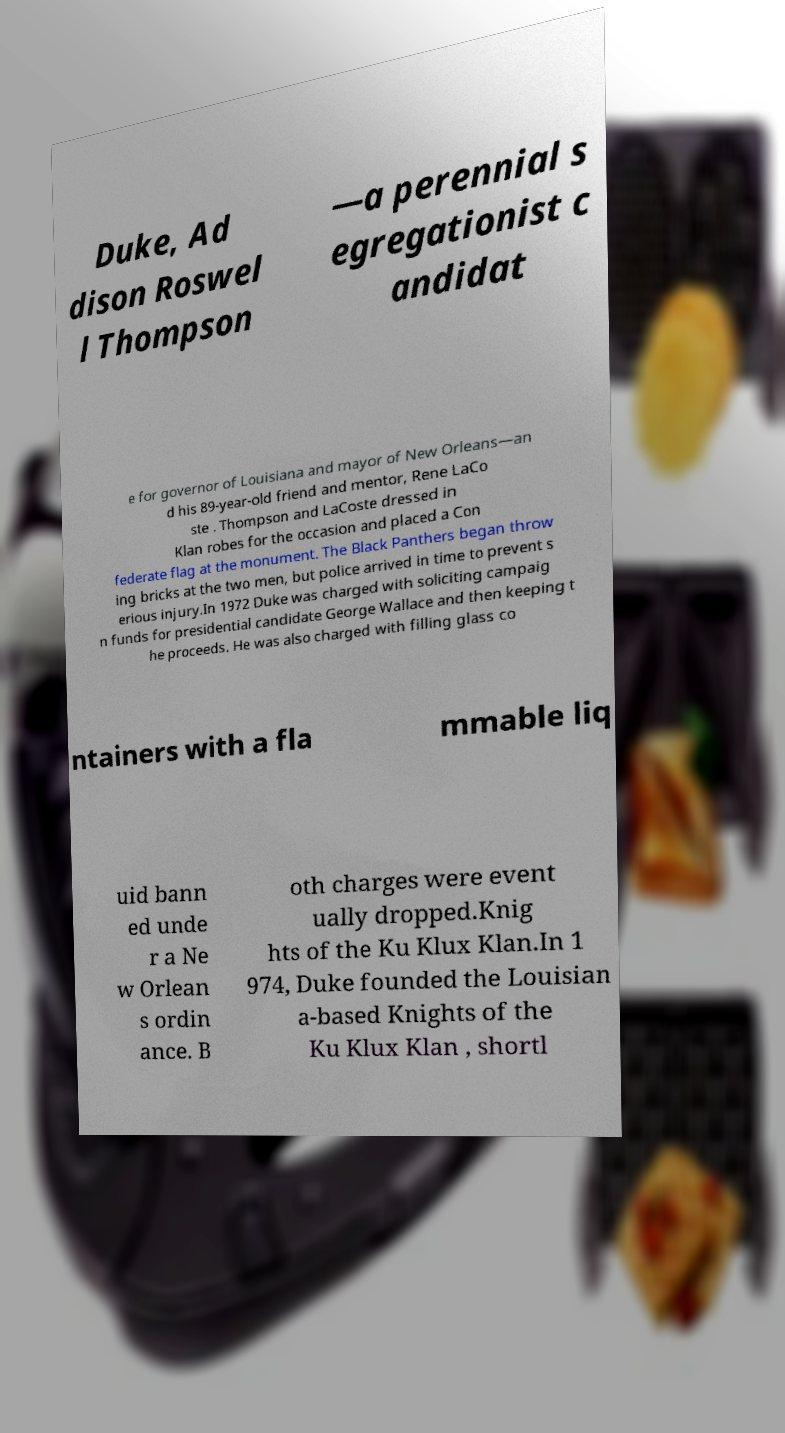Could you extract and type out the text from this image? Duke, Ad dison Roswel l Thompson —a perennial s egregationist c andidat e for governor of Louisiana and mayor of New Orleans—an d his 89-year-old friend and mentor, Rene LaCo ste . Thompson and LaCoste dressed in Klan robes for the occasion and placed a Con federate flag at the monument. The Black Panthers began throw ing bricks at the two men, but police arrived in time to prevent s erious injury.In 1972 Duke was charged with soliciting campaig n funds for presidential candidate George Wallace and then keeping t he proceeds. He was also charged with filling glass co ntainers with a fla mmable liq uid bann ed unde r a Ne w Orlean s ordin ance. B oth charges were event ually dropped.Knig hts of the Ku Klux Klan.In 1 974, Duke founded the Louisian a-based Knights of the Ku Klux Klan , shortl 